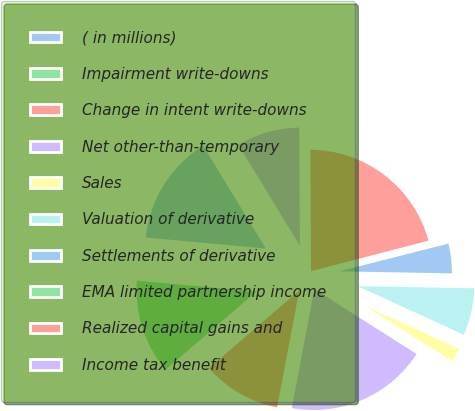Convert chart. <chart><loc_0><loc_0><loc_500><loc_500><pie_chart><fcel>( in millions)<fcel>Impairment write-downs<fcel>Change in intent write-downs<fcel>Net other-than-temporary<fcel>Sales<fcel>Valuation of derivative<fcel>Settlements of derivative<fcel>EMA limited partnership income<fcel>Realized capital gains and<fcel>Income tax benefit<nl><fcel>14.84%<fcel>12.77%<fcel>10.7%<fcel>18.98%<fcel>2.16%<fcel>6.55%<fcel>4.24%<fcel>0.09%<fcel>21.05%<fcel>8.62%<nl></chart> 